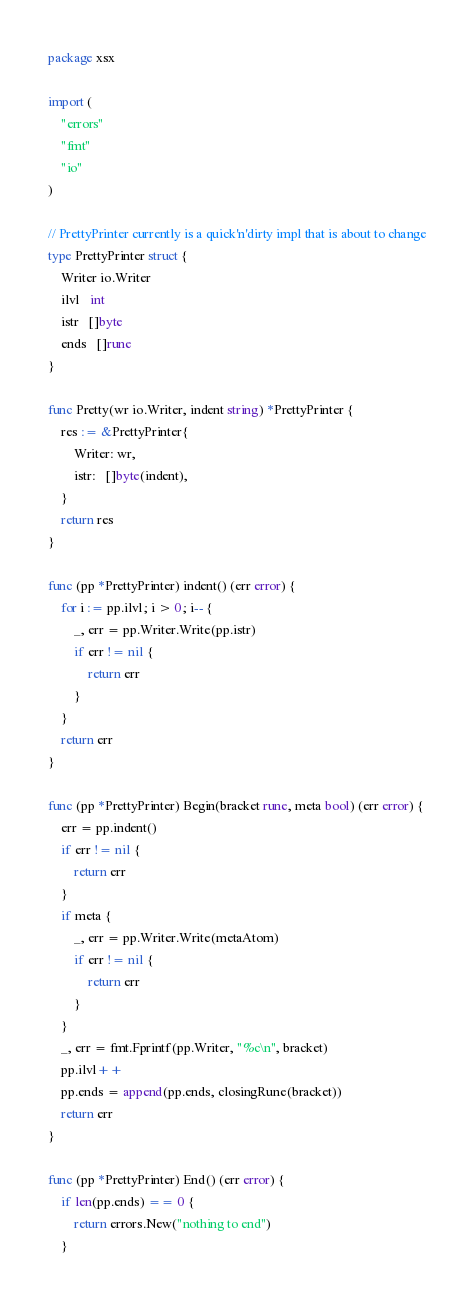Convert code to text. <code><loc_0><loc_0><loc_500><loc_500><_Go_>package xsx

import (
	"errors"
	"fmt"
	"io"
)

// PrettyPrinter currently is a quick'n'dirty impl that is about to change
type PrettyPrinter struct {
	Writer io.Writer
	ilvl   int
	istr   []byte
	ends   []rune
}

func Pretty(wr io.Writer, indent string) *PrettyPrinter {
	res := &PrettyPrinter{
		Writer: wr,
		istr:   []byte(indent),
	}
	return res
}

func (pp *PrettyPrinter) indent() (err error) {
	for i := pp.ilvl; i > 0; i-- {
		_, err = pp.Writer.Write(pp.istr)
		if err != nil {
			return err
		}
	}
	return err
}

func (pp *PrettyPrinter) Begin(bracket rune, meta bool) (err error) {
	err = pp.indent()
	if err != nil {
		return err
	}
	if meta {
		_, err = pp.Writer.Write(metaAtom)
		if err != nil {
			return err
		}
	}
	_, err = fmt.Fprintf(pp.Writer, "%c\n", bracket)
	pp.ilvl++
	pp.ends = append(pp.ends, closingRune(bracket))
	return err
}

func (pp *PrettyPrinter) End() (err error) {
	if len(pp.ends) == 0 {
		return errors.New("nothing to end")
	}</code> 